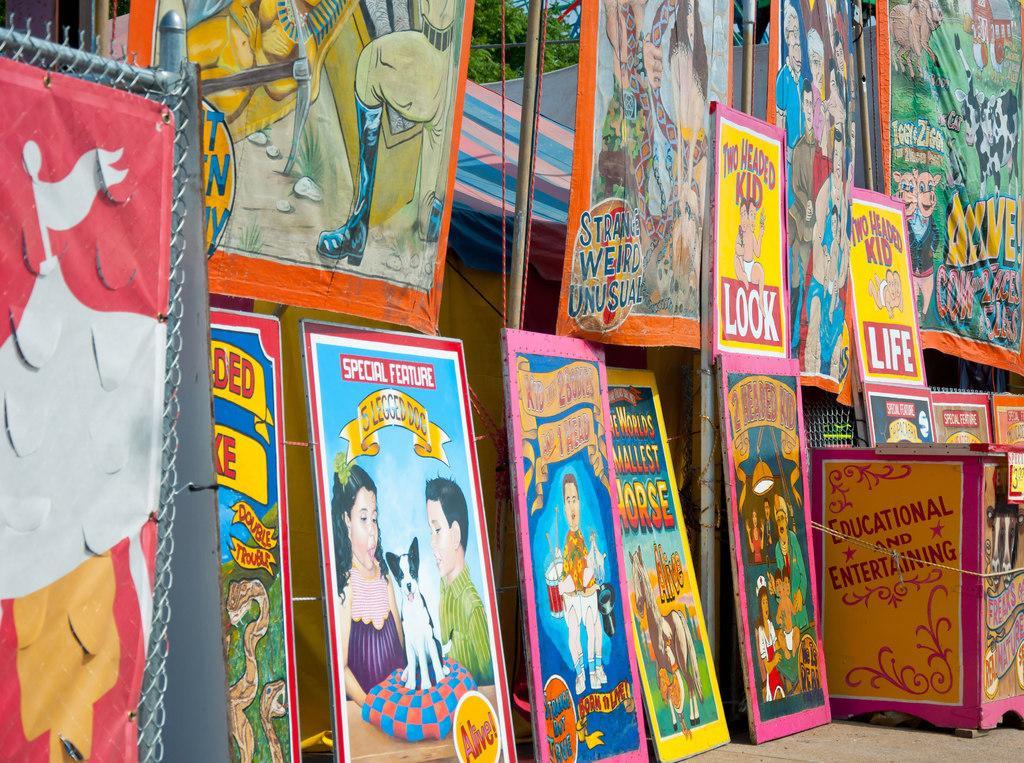Could you give a brief overview of what you see in this image? In this image I can see few boards and banners and I can see few cartoon pictures on the boards. In the background I can see the railing, few tents and trees in green color and the sky is in blue color. 